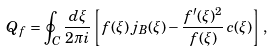Convert formula to latex. <formula><loc_0><loc_0><loc_500><loc_500>Q _ { f } = \oint _ { C } \frac { d \xi } { 2 \pi i } \left [ f ( \xi ) \, j _ { B } ( \xi ) - \frac { f ^ { \prime } ( \xi ) ^ { 2 } } { f ( \xi ) } \, c ( \xi ) \right ] \, ,</formula> 